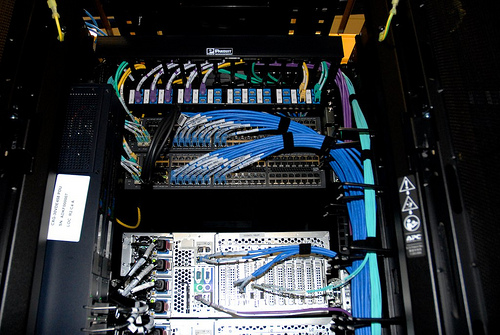<image>
Is the cable above the port? Yes. The cable is positioned above the port in the vertical space, higher up in the scene. 